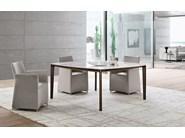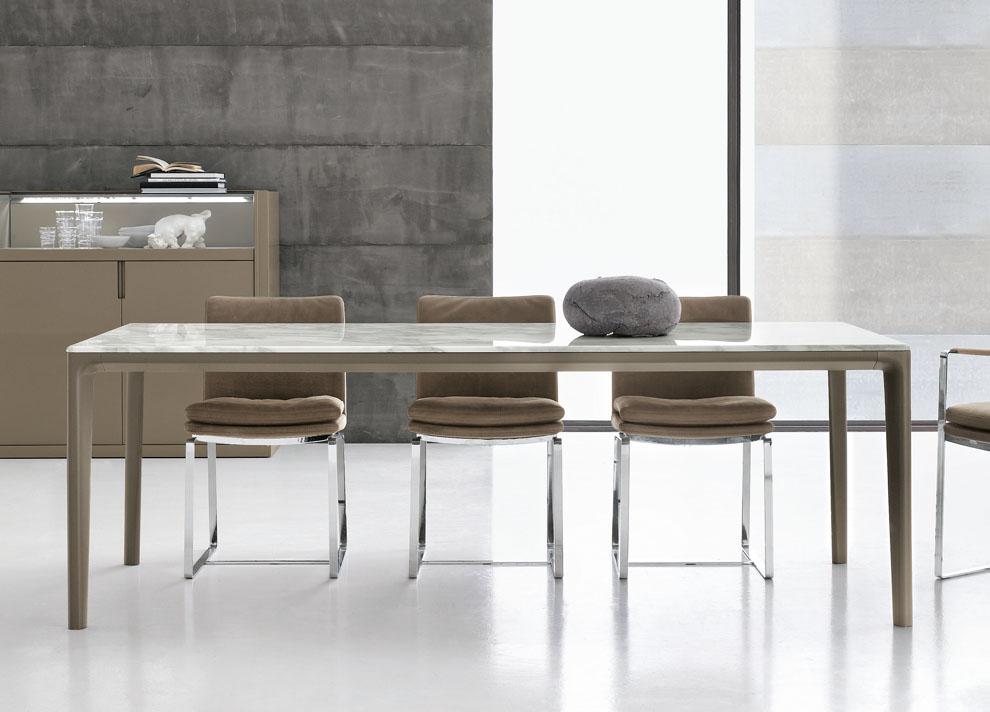The first image is the image on the left, the second image is the image on the right. Assess this claim about the two images: "One of the tables is round.". Correct or not? Answer yes or no. No. The first image is the image on the left, the second image is the image on the right. Examine the images to the left and right. Is the description "A table in one image is round with two chairs." accurate? Answer yes or no. No. 